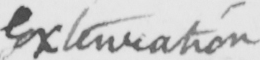Please provide the text content of this handwritten line. Extenuation 